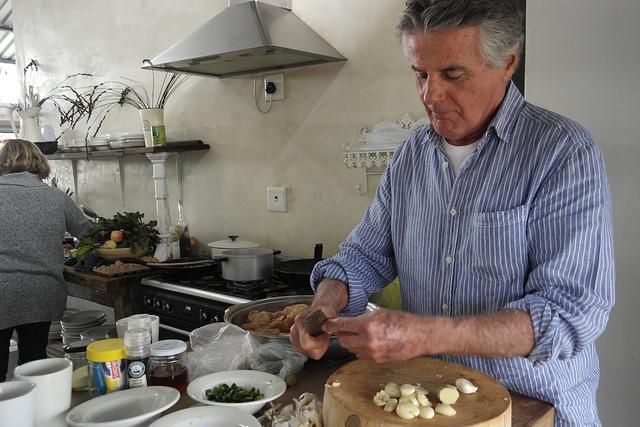How many people are there?
Give a very brief answer. 2. How many ovens are in the picture?
Give a very brief answer. 1. How many dining tables are there?
Give a very brief answer. 1. How many potted plants are visible?
Give a very brief answer. 2. How many bowls are there?
Give a very brief answer. 3. How many ski poles are to the right of the skier?
Give a very brief answer. 0. 